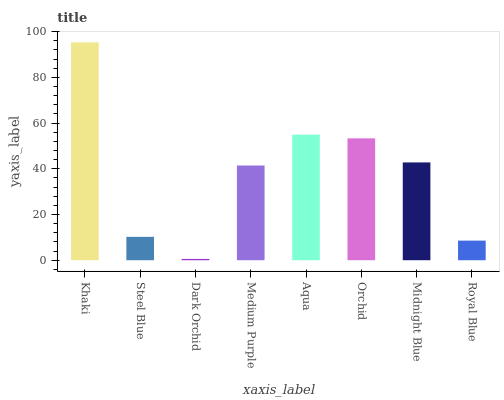Is Dark Orchid the minimum?
Answer yes or no. Yes. Is Khaki the maximum?
Answer yes or no. Yes. Is Steel Blue the minimum?
Answer yes or no. No. Is Steel Blue the maximum?
Answer yes or no. No. Is Khaki greater than Steel Blue?
Answer yes or no. Yes. Is Steel Blue less than Khaki?
Answer yes or no. Yes. Is Steel Blue greater than Khaki?
Answer yes or no. No. Is Khaki less than Steel Blue?
Answer yes or no. No. Is Midnight Blue the high median?
Answer yes or no. Yes. Is Medium Purple the low median?
Answer yes or no. Yes. Is Orchid the high median?
Answer yes or no. No. Is Royal Blue the low median?
Answer yes or no. No. 